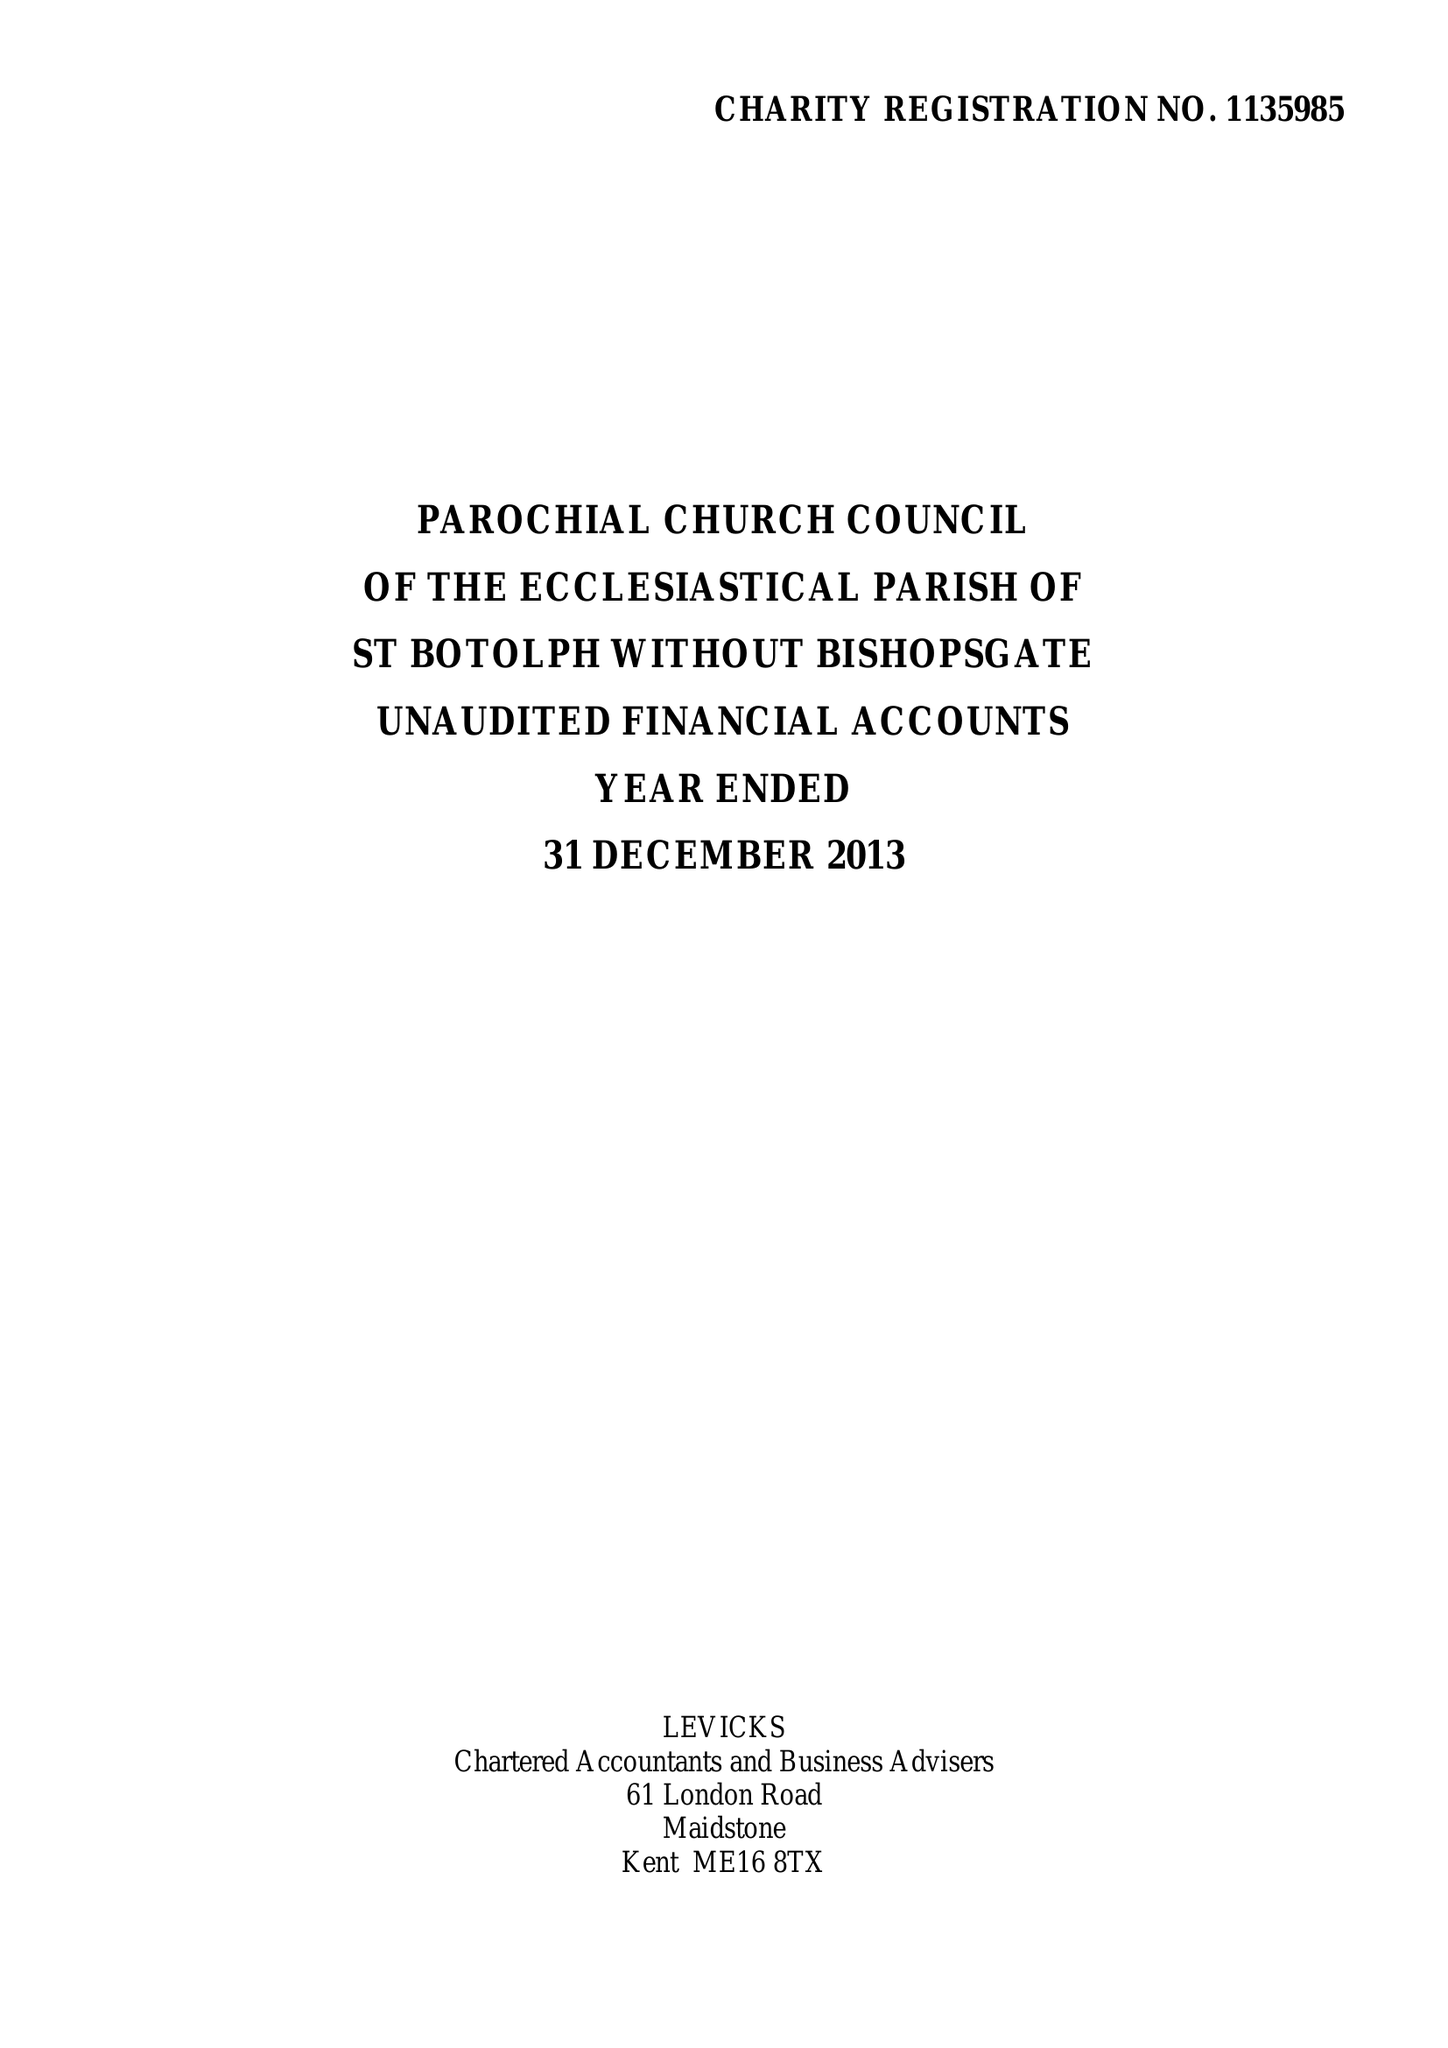What is the value for the address__post_town?
Answer the question using a single word or phrase. LONDON 